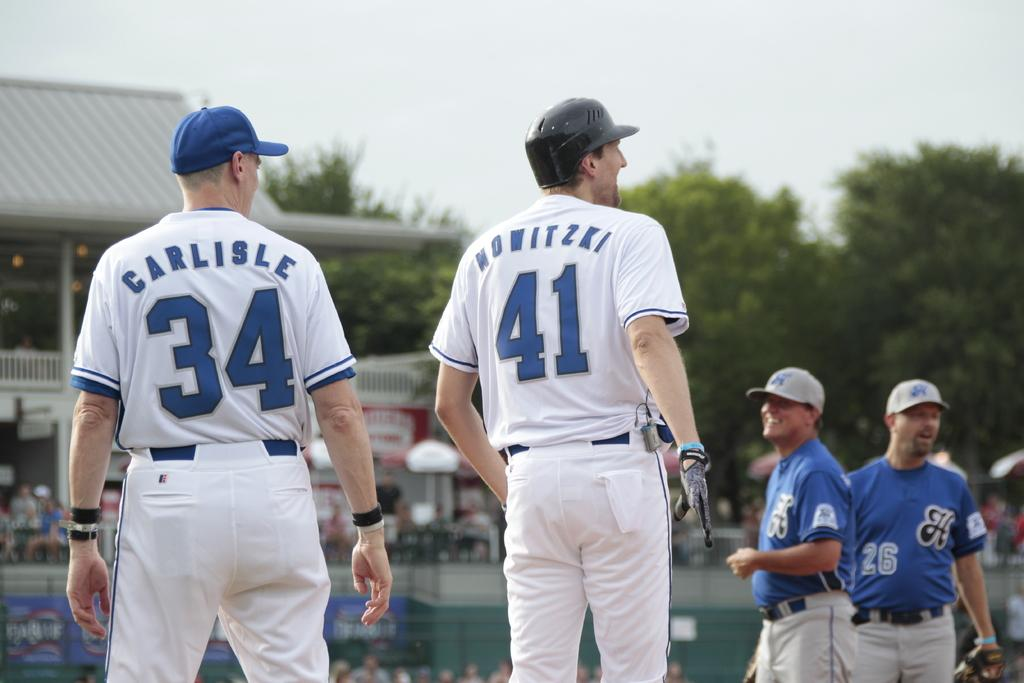<image>
Give a short and clear explanation of the subsequent image. several baseball players are standing near each other with one having the number 41 on his back. 